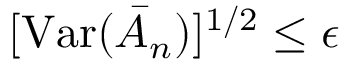Convert formula to latex. <formula><loc_0><loc_0><loc_500><loc_500>[ V a r ( \bar { A } _ { n } ) ] ^ { 1 / 2 } \leq \epsilon</formula> 